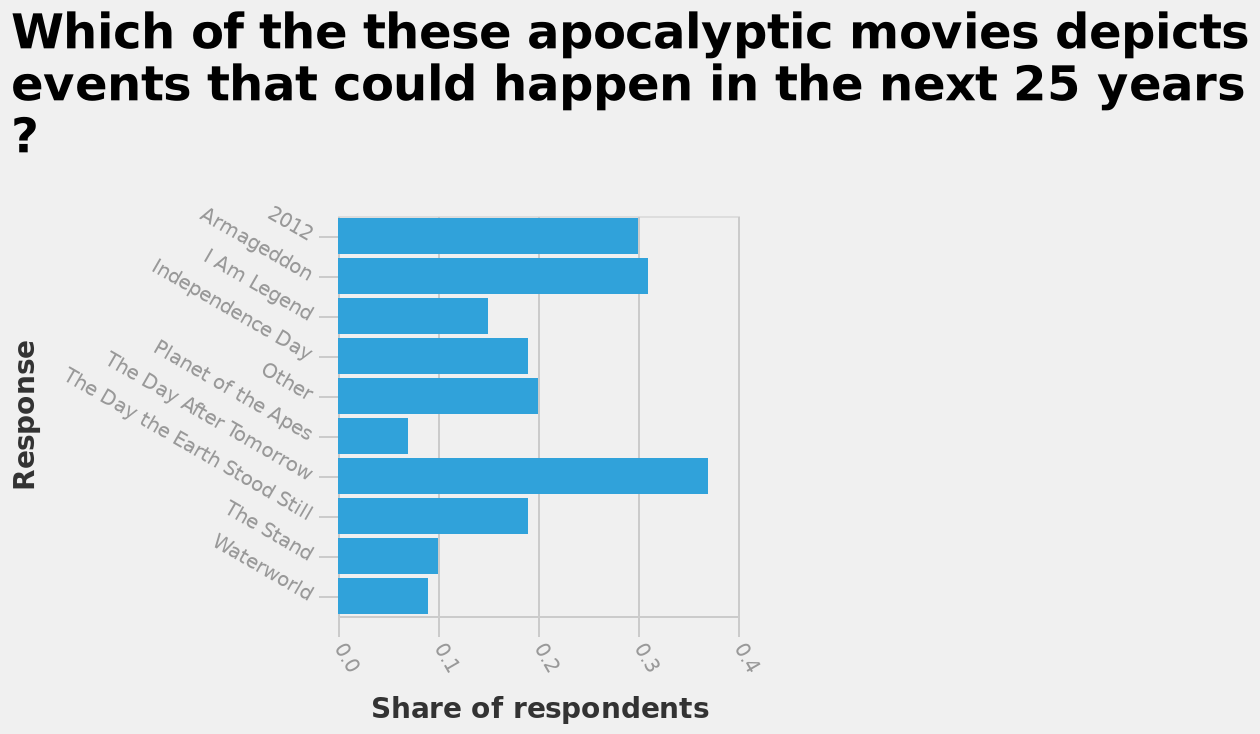<image>
Which movie is represented on the y-axis at the opposite end of 2012? Waterworld is represented on the y-axis at the opposite end of 2012. Offer a thorough analysis of the image. The movies which have been mentioned by the lowest number of respondents are Planet of the Apes, The Stand, and Waterworld. The movies which have been mentioned the most are 2012, Armageddon, and The Day After Tomorrow. The least mentioned movie is Planet of the Apes, and the most mentioned one is The Day After Tomorrow. What is the least mentioned movie?  Planet of the Apes. Can you name three movies mentioned by the lowest number of respondents? Planet of the Apes, The Stand, and Waterworld. What is the maximum value represented on the x-axis? The maximum value represented on the x-axis is 0.4. 